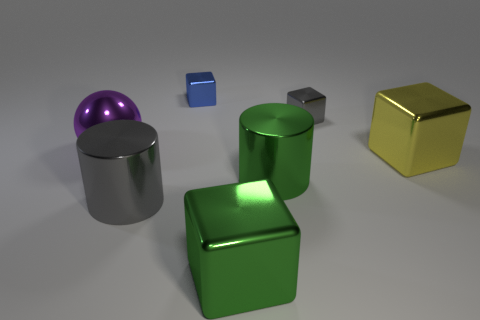Is there anything else of the same color as the metal ball?
Make the answer very short. No. There is a small object on the left side of the tiny gray shiny block; does it have the same color as the big metal cube in front of the yellow metal object?
Keep it short and to the point. No. Is the number of gray objects that are in front of the large green metallic cube greater than the number of large green metallic objects that are in front of the tiny gray metallic block?
Keep it short and to the point. No. What is the material of the small blue object?
Your answer should be very brief. Metal. The small gray object behind the large thing that is in front of the gray shiny thing that is in front of the gray cube is what shape?
Offer a very short reply. Cube. What number of other objects are the same material as the green cylinder?
Ensure brevity in your answer.  6. Are the gray object that is behind the purple metal sphere and the block in front of the yellow cube made of the same material?
Provide a short and direct response. Yes. What number of shiny things are to the left of the yellow metal block and behind the large gray cylinder?
Offer a very short reply. 4. Is there another large thing of the same shape as the large yellow metallic thing?
Offer a very short reply. Yes. There is another object that is the same size as the blue thing; what is its shape?
Your answer should be very brief. Cube. 